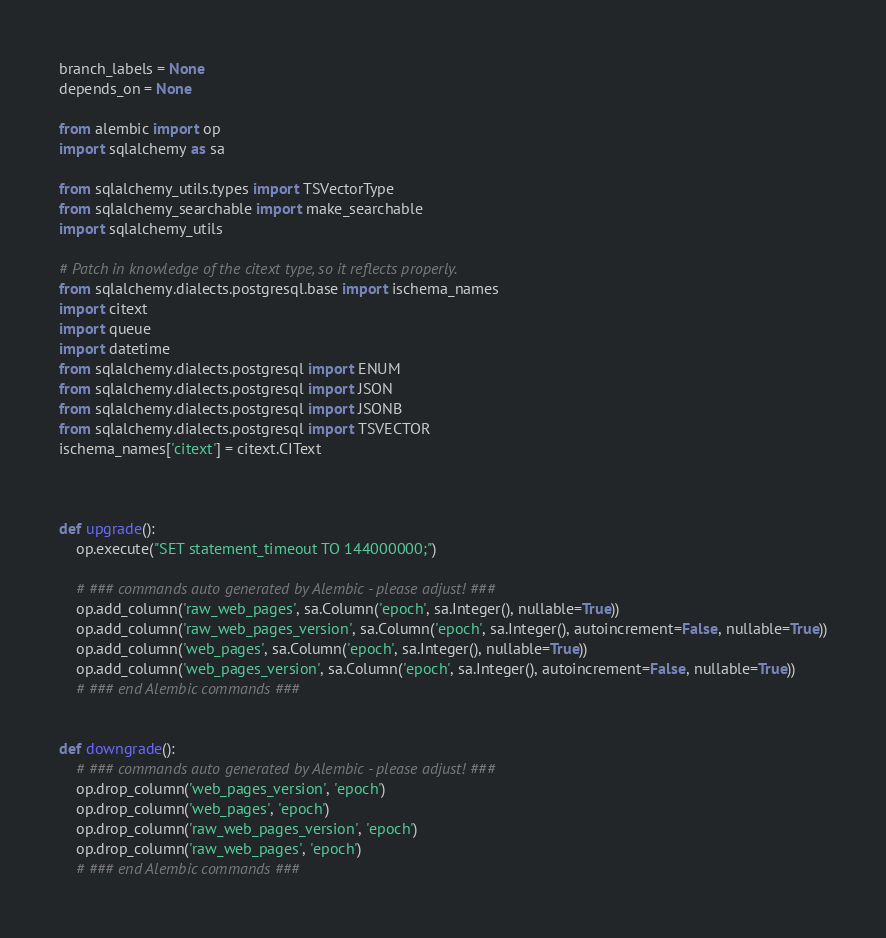<code> <loc_0><loc_0><loc_500><loc_500><_Python_>branch_labels = None
depends_on = None

from alembic import op
import sqlalchemy as sa

from sqlalchemy_utils.types import TSVectorType
from sqlalchemy_searchable import make_searchable
import sqlalchemy_utils

# Patch in knowledge of the citext type, so it reflects properly.
from sqlalchemy.dialects.postgresql.base import ischema_names
import citext
import queue
import datetime
from sqlalchemy.dialects.postgresql import ENUM
from sqlalchemy.dialects.postgresql import JSON
from sqlalchemy.dialects.postgresql import JSONB
from sqlalchemy.dialects.postgresql import TSVECTOR
ischema_names['citext'] = citext.CIText



def upgrade():
    op.execute("SET statement_timeout TO 144000000;")

    # ### commands auto generated by Alembic - please adjust! ###
    op.add_column('raw_web_pages', sa.Column('epoch', sa.Integer(), nullable=True))
    op.add_column('raw_web_pages_version', sa.Column('epoch', sa.Integer(), autoincrement=False, nullable=True))
    op.add_column('web_pages', sa.Column('epoch', sa.Integer(), nullable=True))
    op.add_column('web_pages_version', sa.Column('epoch', sa.Integer(), autoincrement=False, nullable=True))
    # ### end Alembic commands ###


def downgrade():
    # ### commands auto generated by Alembic - please adjust! ###
    op.drop_column('web_pages_version', 'epoch')
    op.drop_column('web_pages', 'epoch')
    op.drop_column('raw_web_pages_version', 'epoch')
    op.drop_column('raw_web_pages', 'epoch')
    # ### end Alembic commands ###
</code> 